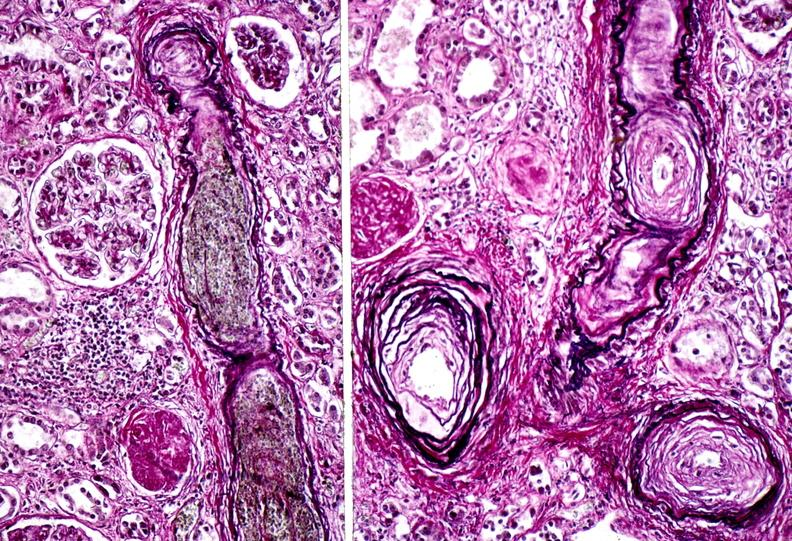does this image show kidney, arteriolonephrosclerosis, malignant hypertension?
Answer the question using a single word or phrase. Yes 